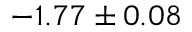<formula> <loc_0><loc_0><loc_500><loc_500>- 1 . 7 7 \pm 0 . 0 8</formula> 